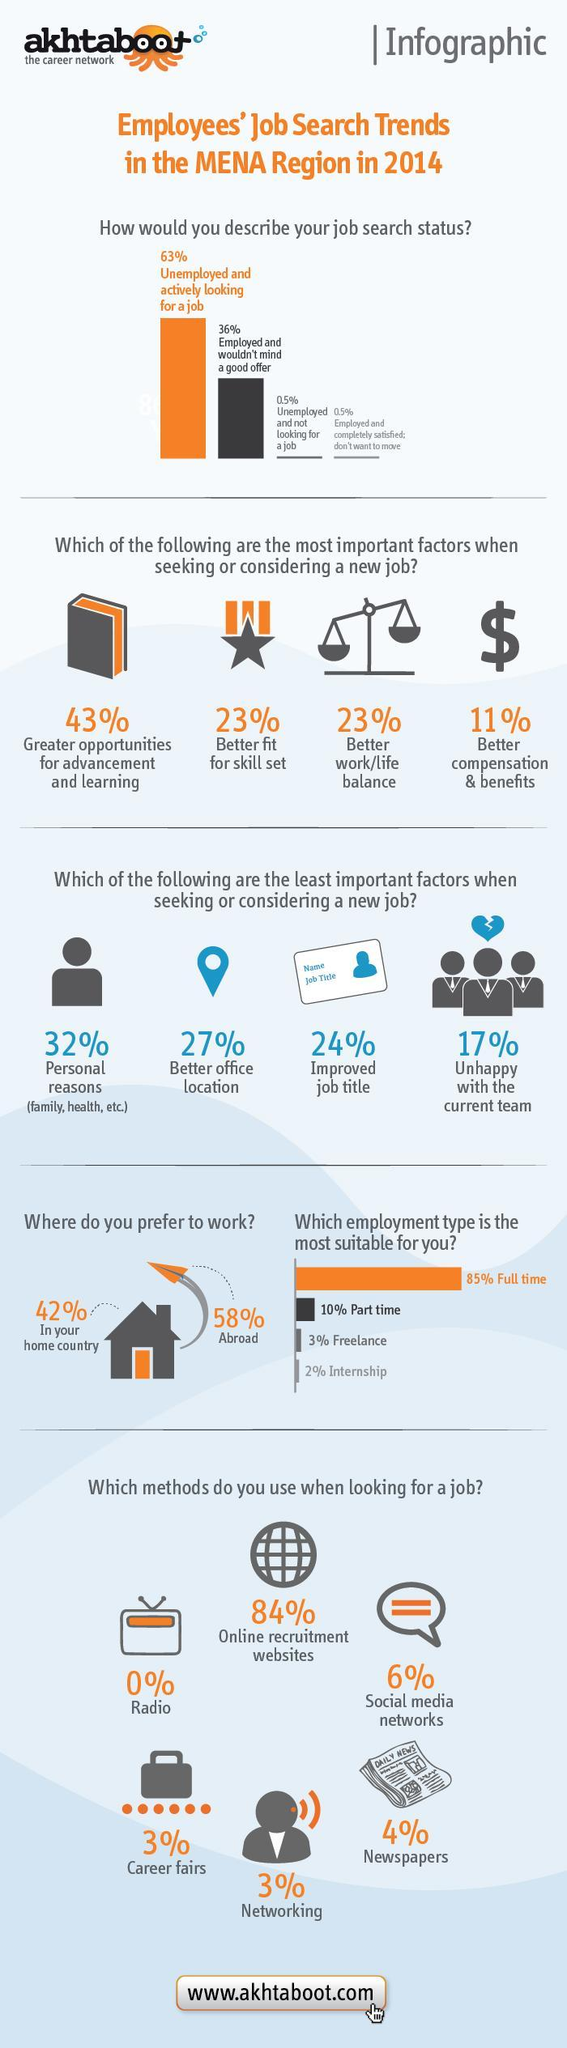what is the total % who find freelance or internship more suitable
Answer the question with a short phrase. 5 How many look for a better work/life balance when considering a new job 23% what does the $ sign indicate when considering a new job better compensation & benefits how many people prefer working outside their home country 58% what is the total% of unemployed and not looking for a job and employed and completely satisfied with no intention to move 1 which media or method is never used when looking for a job radio 